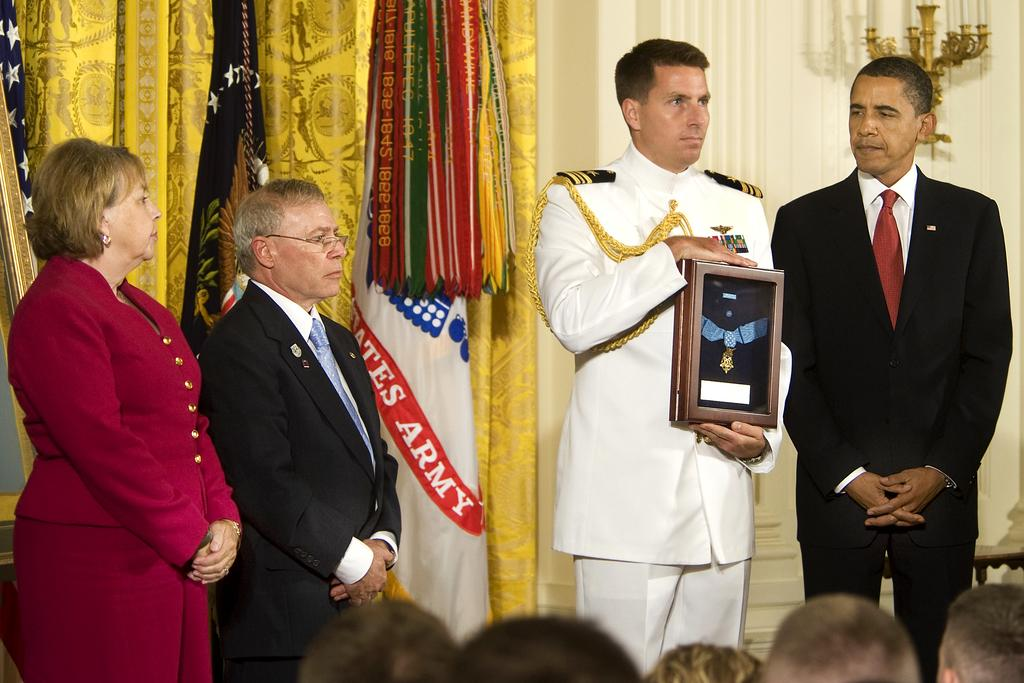<image>
Offer a succinct explanation of the picture presented. Several people are gathered in front of some flags, including one for the United States Army. 